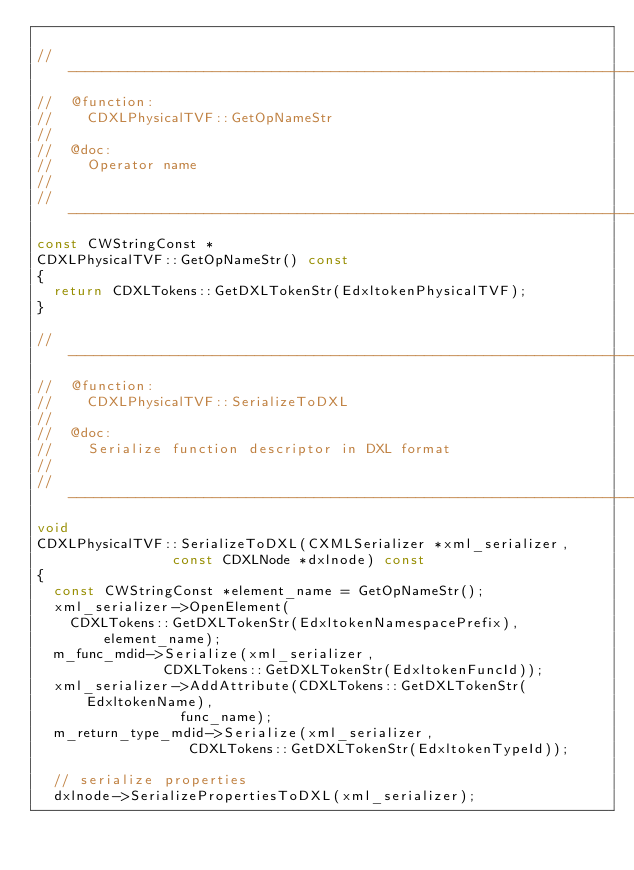<code> <loc_0><loc_0><loc_500><loc_500><_C++_>
//---------------------------------------------------------------------------
//	@function:
//		CDXLPhysicalTVF::GetOpNameStr
//
//	@doc:
//		Operator name
//
//---------------------------------------------------------------------------
const CWStringConst *
CDXLPhysicalTVF::GetOpNameStr() const
{
	return CDXLTokens::GetDXLTokenStr(EdxltokenPhysicalTVF);
}

//---------------------------------------------------------------------------
//	@function:
//		CDXLPhysicalTVF::SerializeToDXL
//
//	@doc:
//		Serialize function descriptor in DXL format
//
//---------------------------------------------------------------------------
void
CDXLPhysicalTVF::SerializeToDXL(CXMLSerializer *xml_serializer,
								const CDXLNode *dxlnode) const
{
	const CWStringConst *element_name = GetOpNameStr();
	xml_serializer->OpenElement(
		CDXLTokens::GetDXLTokenStr(EdxltokenNamespacePrefix), element_name);
	m_func_mdid->Serialize(xml_serializer,
						   CDXLTokens::GetDXLTokenStr(EdxltokenFuncId));
	xml_serializer->AddAttribute(CDXLTokens::GetDXLTokenStr(EdxltokenName),
								 func_name);
	m_return_type_mdid->Serialize(xml_serializer,
								  CDXLTokens::GetDXLTokenStr(EdxltokenTypeId));

	// serialize properties
	dxlnode->SerializePropertiesToDXL(xml_serializer);
</code> 